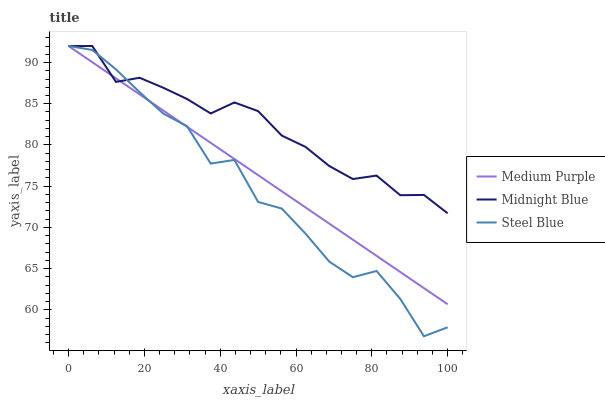Does Steel Blue have the minimum area under the curve?
Answer yes or no. Yes. Does Midnight Blue have the maximum area under the curve?
Answer yes or no. Yes. Does Midnight Blue have the minimum area under the curve?
Answer yes or no. No. Does Steel Blue have the maximum area under the curve?
Answer yes or no. No. Is Medium Purple the smoothest?
Answer yes or no. Yes. Is Steel Blue the roughest?
Answer yes or no. Yes. Is Midnight Blue the smoothest?
Answer yes or no. No. Is Midnight Blue the roughest?
Answer yes or no. No. Does Steel Blue have the lowest value?
Answer yes or no. Yes. Does Midnight Blue have the lowest value?
Answer yes or no. No. Does Steel Blue have the highest value?
Answer yes or no. Yes. Does Medium Purple intersect Steel Blue?
Answer yes or no. Yes. Is Medium Purple less than Steel Blue?
Answer yes or no. No. Is Medium Purple greater than Steel Blue?
Answer yes or no. No. 